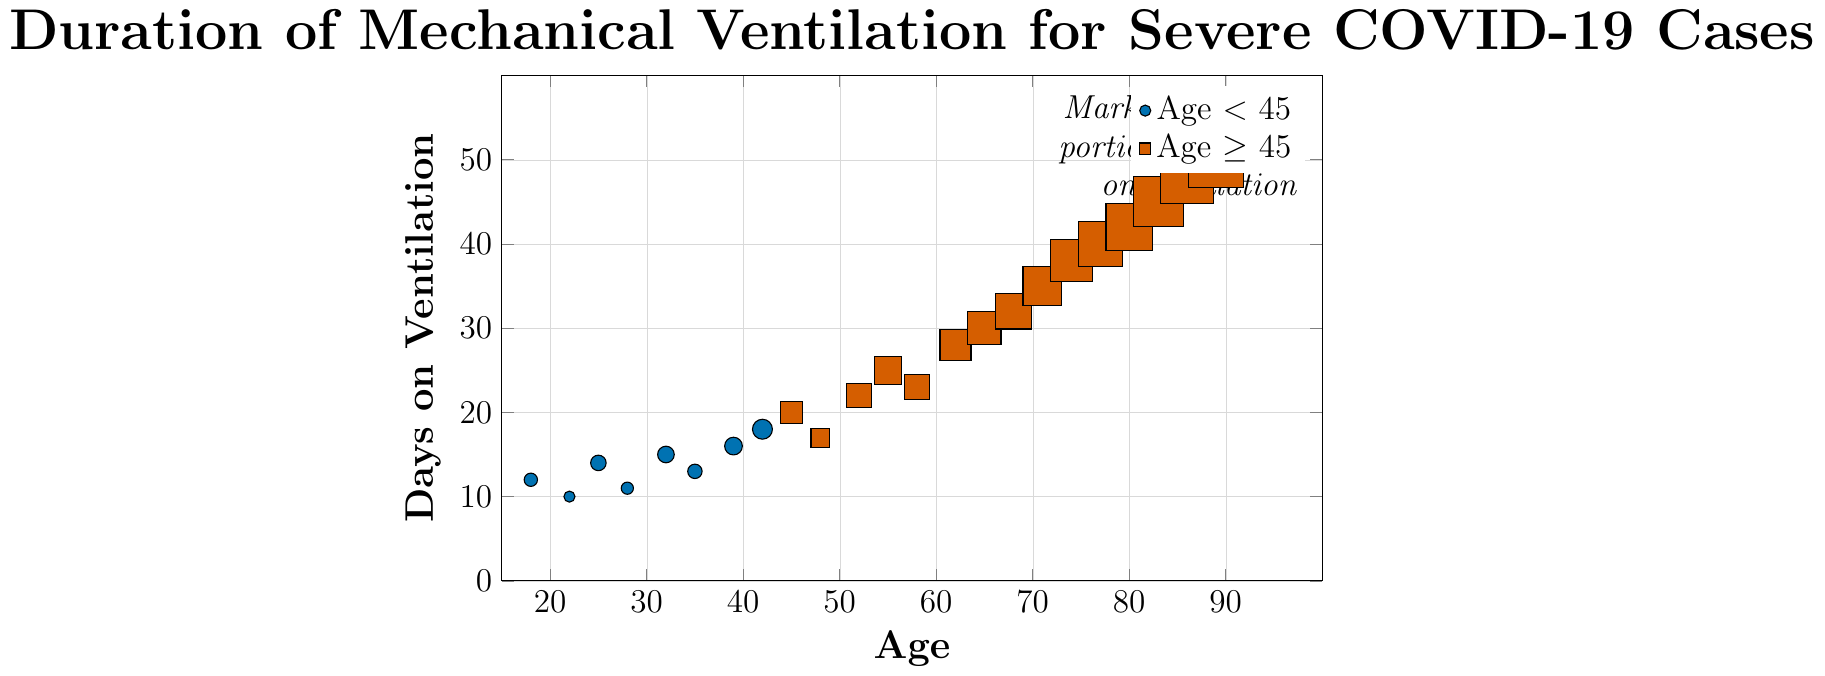How many days on ventilation does the 65-year-old patient have? Locate the dot corresponding to the age 65 on the x-axis and read its y-axis value representing the days on ventilation.
Answer: 30 Is there a general trend between age and days on ventilation? Observe the scatter plot and see if the dots generally form a pattern or trend as age increases. The dots appear to follow an upwards trend, indicating that older patients tend to require more days on mechanical ventilation.
Answer: Yes, older patients seem to be on ventilation longer What is the average duration of mechanical ventilation for patients aged 45 and older? Identify all patients aged 45 and older, then sum their days on ventilation and divide by the number of these patients. Calculation: (20+17+22+25+23+28+30+32+35+38+40+42+45+48+50+52+55) / 17 = 40.29
Answer: 40.29 Are there more patients aged under 45 or 45 and older? Count the number of dots on the left side of age 45 and on the right side. Ages under 45: 8 patients, Ages 45 and older: 17 patients.
Answer: More patients aged 45 and older Which patient has the longest duration of mechanical ventilation, and how old are they? Locate the dot at the highest point on the y-axis, representing the longest duration. This dot corresponds to an age of 95 with 55 days on ventilation.
Answer: 95 years old with 55 days on ventilation What is the difference in ventilation duration between the youngest and oldest patients? Subtract the number of days on ventilation of the youngest patient (12 days for age 18) from that of the oldest patient (55 days for age 95). 55 - 12 = 43
Answer: 43 By how many days does the ventilation duration increase for every 10-year age increment, on average? Select a few age increments and calculate the differences in ventilation days, then average the results. For instance, from 22 to 32 (10 years), the increase is 15 - 10 = 5 days. From 42 to 52, the increase is 22 - 18 = 4 days. (5 + 4) / 2 = 4.5 days. Repeat for more intervals for accuracy.
Answer: Approximately 4.5 days Which age group, under 45 or 45 and older, has the greatest variability in days on ventilation? Examine the spread of dots for both age groups. Patients under 45 have days ranging from 10 to 20 (10-day range). Patients aged 45 and older have a range from 17 to 55 (38-day range). Greater range means greater variability.
Answer: Age 45 and older 